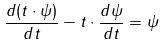Convert formula to latex. <formula><loc_0><loc_0><loc_500><loc_500>\frac { d ( t \cdot \psi ) } { d t } - t \cdot \frac { d \psi } { d t } = \psi</formula> 